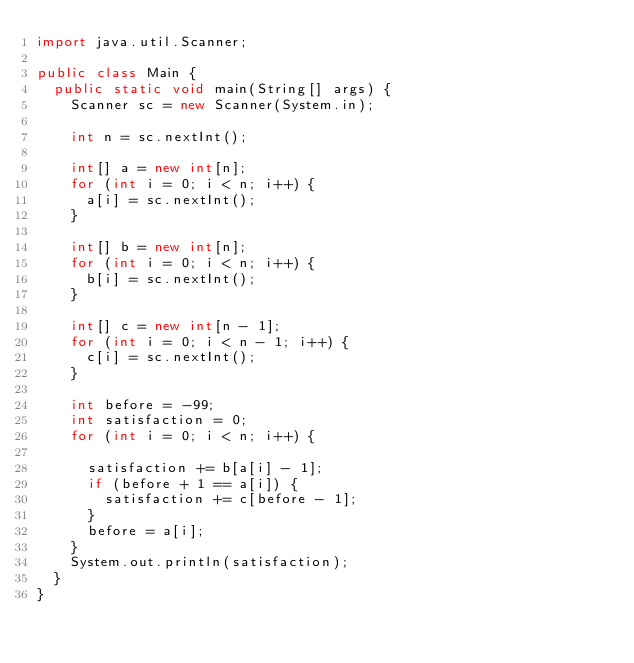Convert code to text. <code><loc_0><loc_0><loc_500><loc_500><_Java_>import java.util.Scanner;

public class Main {
  public static void main(String[] args) {
    Scanner sc = new Scanner(System.in);

    int n = sc.nextInt();

    int[] a = new int[n];
    for (int i = 0; i < n; i++) {
      a[i] = sc.nextInt();
    }

    int[] b = new int[n];
    for (int i = 0; i < n; i++) {
      b[i] = sc.nextInt();
    }

    int[] c = new int[n - 1];
    for (int i = 0; i < n - 1; i++) {
      c[i] = sc.nextInt();
    }

    int before = -99;
    int satisfaction = 0;
    for (int i = 0; i < n; i++) {

      satisfaction += b[a[i] - 1];
      if (before + 1 == a[i]) {
        satisfaction += c[before - 1];
      }
      before = a[i];
    }
    System.out.println(satisfaction);
  }
}
</code> 